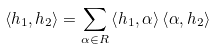<formula> <loc_0><loc_0><loc_500><loc_500>\left < h _ { 1 } , h _ { 2 } \right > = \sum _ { \alpha \in R } \left < h _ { 1 } , \alpha \right > \left < \alpha , h _ { 2 } \right ></formula> 